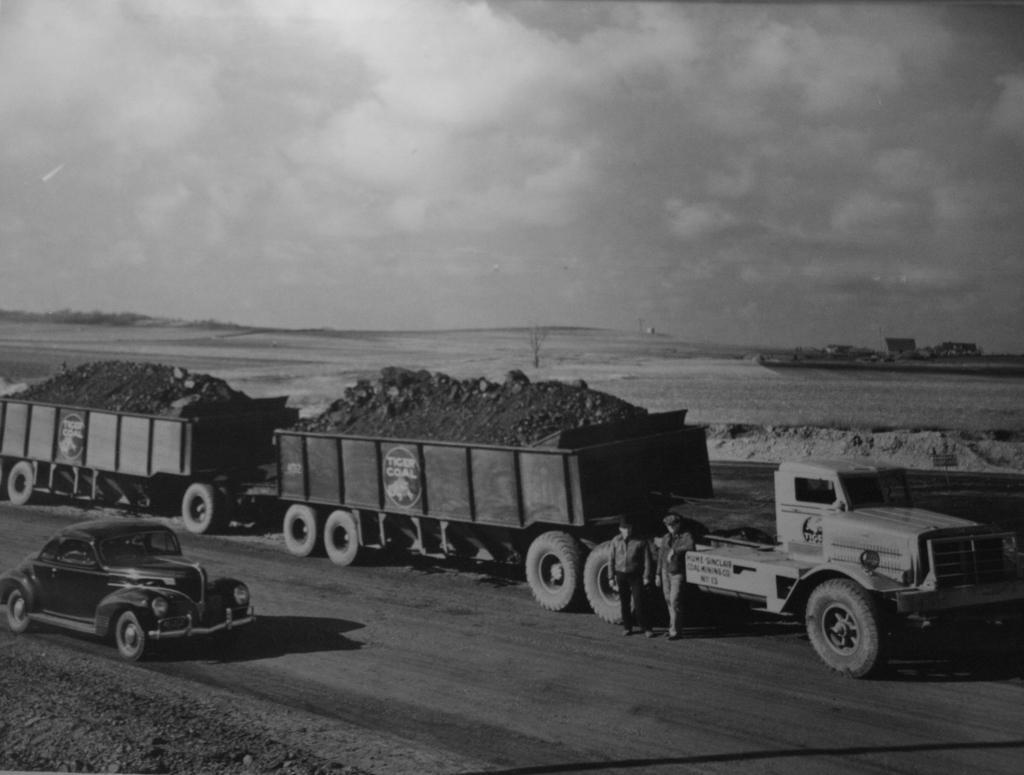How would you summarize this image in a sentence or two? This is a black and white image. There are vehicles and few people on the road. There is land at the back. 